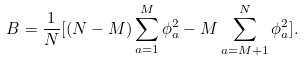<formula> <loc_0><loc_0><loc_500><loc_500>B = \frac { 1 } { N } [ ( N - M ) \sum _ { a = 1 } ^ { M } \phi _ { a } ^ { 2 } - M \sum _ { a = M + 1 } ^ { N } \phi _ { a } ^ { 2 } ] .</formula> 